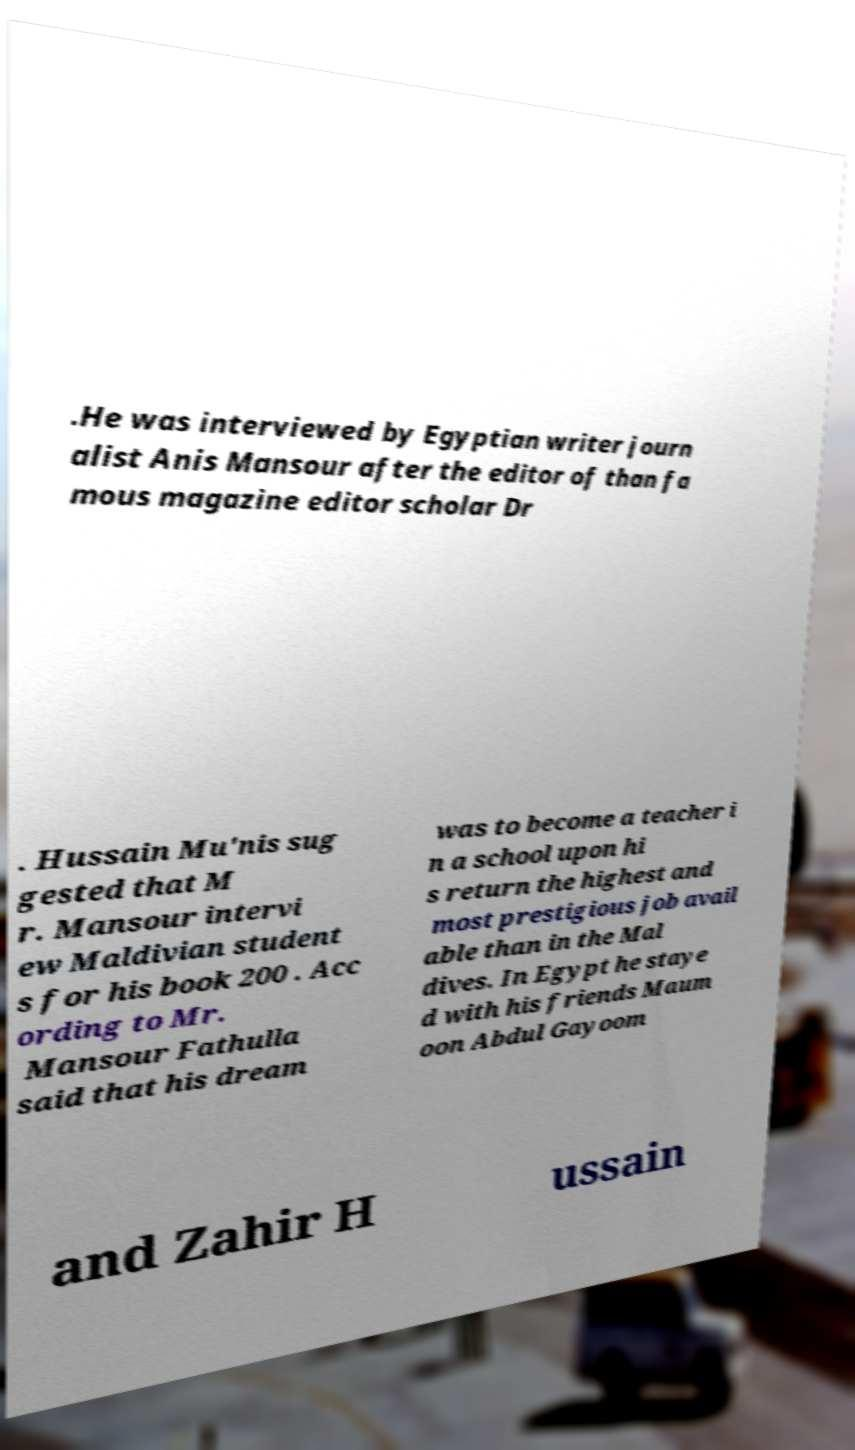Could you assist in decoding the text presented in this image and type it out clearly? .He was interviewed by Egyptian writer journ alist Anis Mansour after the editor of than fa mous magazine editor scholar Dr . Hussain Mu'nis sug gested that M r. Mansour intervi ew Maldivian student s for his book 200 . Acc ording to Mr. Mansour Fathulla said that his dream was to become a teacher i n a school upon hi s return the highest and most prestigious job avail able than in the Mal dives. In Egypt he staye d with his friends Maum oon Abdul Gayoom and Zahir H ussain 